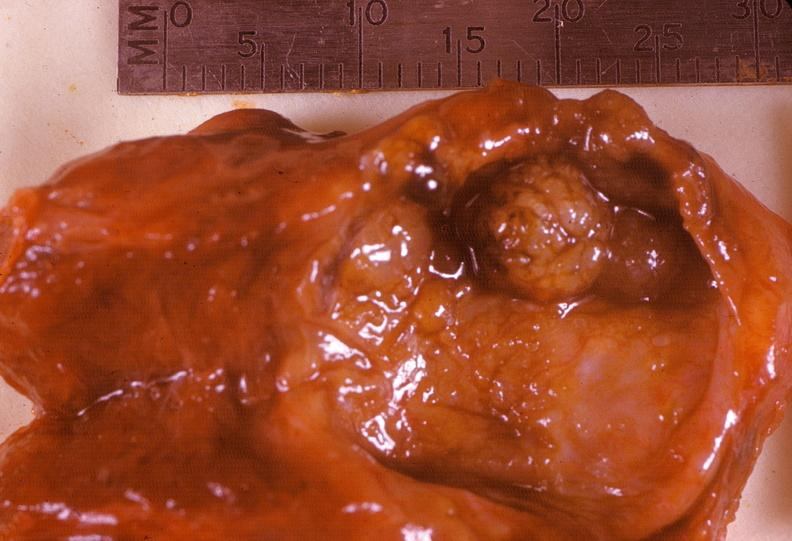does anencephaly show thyroid, follicular adenoma, cystic?
Answer the question using a single word or phrase. No 